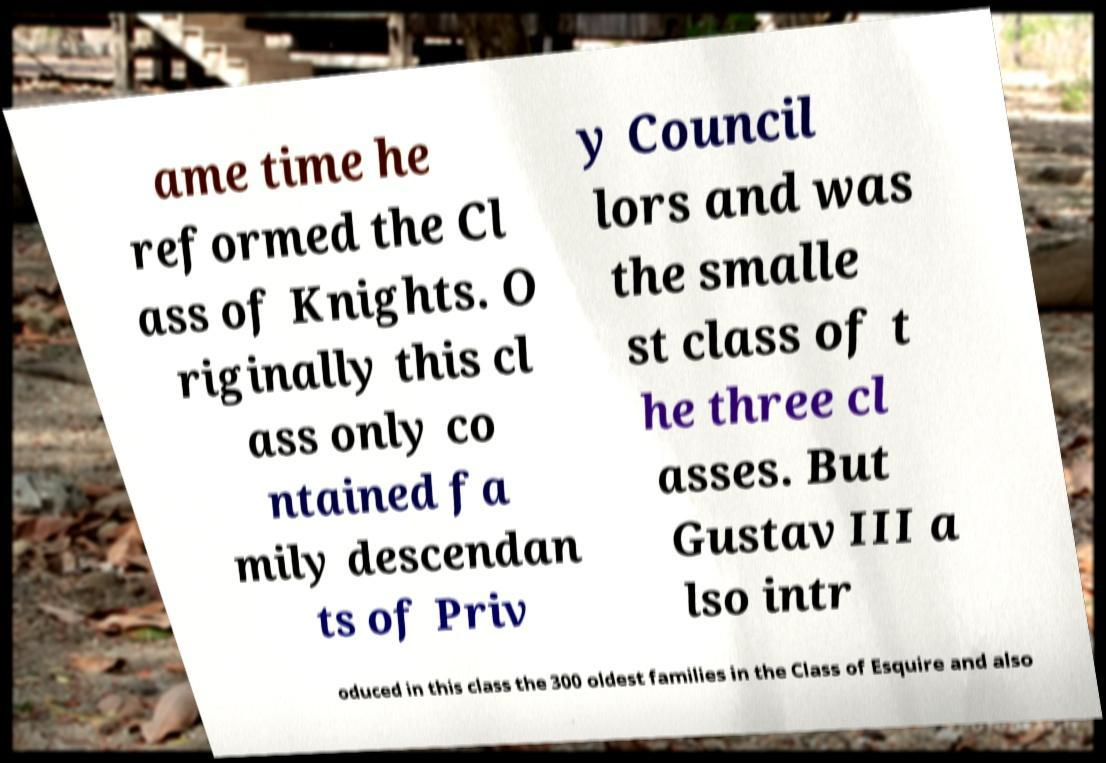Please read and relay the text visible in this image. What does it say? ame time he reformed the Cl ass of Knights. O riginally this cl ass only co ntained fa mily descendan ts of Priv y Council lors and was the smalle st class of t he three cl asses. But Gustav III a lso intr oduced in this class the 300 oldest families in the Class of Esquire and also 